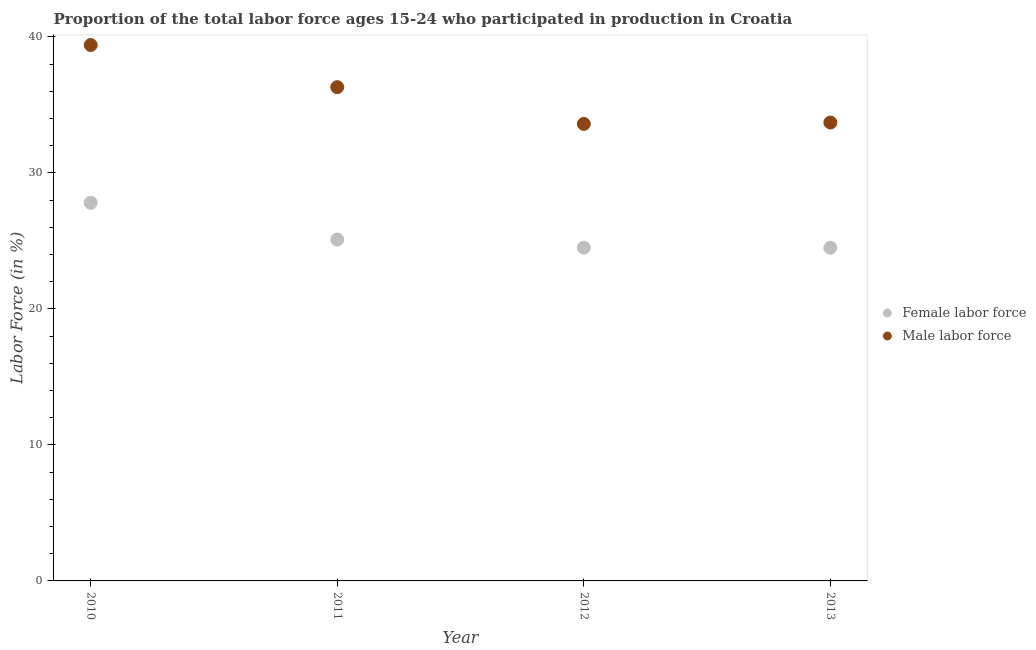How many different coloured dotlines are there?
Your answer should be very brief. 2. What is the percentage of female labor force in 2011?
Offer a very short reply. 25.1. Across all years, what is the maximum percentage of female labor force?
Provide a succinct answer. 27.8. Across all years, what is the minimum percentage of male labour force?
Ensure brevity in your answer.  33.6. In which year was the percentage of male labour force maximum?
Provide a short and direct response. 2010. In which year was the percentage of male labour force minimum?
Your answer should be compact. 2012. What is the total percentage of male labour force in the graph?
Make the answer very short. 143. What is the difference between the percentage of male labour force in 2010 and that in 2012?
Offer a very short reply. 5.8. What is the difference between the percentage of male labour force in 2011 and the percentage of female labor force in 2013?
Your answer should be very brief. 11.8. What is the average percentage of male labour force per year?
Ensure brevity in your answer.  35.75. In the year 2010, what is the difference between the percentage of male labour force and percentage of female labor force?
Offer a very short reply. 11.6. What is the ratio of the percentage of female labor force in 2010 to that in 2011?
Give a very brief answer. 1.11. Is the percentage of female labor force in 2011 less than that in 2013?
Provide a short and direct response. No. Is the difference between the percentage of female labor force in 2012 and 2013 greater than the difference between the percentage of male labour force in 2012 and 2013?
Offer a very short reply. Yes. What is the difference between the highest and the second highest percentage of female labor force?
Provide a succinct answer. 2.7. What is the difference between the highest and the lowest percentage of female labor force?
Keep it short and to the point. 3.3. In how many years, is the percentage of male labour force greater than the average percentage of male labour force taken over all years?
Your answer should be compact. 2. Is the percentage of female labor force strictly less than the percentage of male labour force over the years?
Keep it short and to the point. Yes. How many years are there in the graph?
Provide a succinct answer. 4. What is the difference between two consecutive major ticks on the Y-axis?
Your answer should be compact. 10. Are the values on the major ticks of Y-axis written in scientific E-notation?
Ensure brevity in your answer.  No. Does the graph contain grids?
Provide a succinct answer. No. What is the title of the graph?
Provide a short and direct response. Proportion of the total labor force ages 15-24 who participated in production in Croatia. Does "Arms imports" appear as one of the legend labels in the graph?
Your response must be concise. No. What is the label or title of the X-axis?
Your response must be concise. Year. What is the Labor Force (in %) of Female labor force in 2010?
Make the answer very short. 27.8. What is the Labor Force (in %) in Male labor force in 2010?
Ensure brevity in your answer.  39.4. What is the Labor Force (in %) of Female labor force in 2011?
Make the answer very short. 25.1. What is the Labor Force (in %) in Male labor force in 2011?
Ensure brevity in your answer.  36.3. What is the Labor Force (in %) of Female labor force in 2012?
Provide a short and direct response. 24.5. What is the Labor Force (in %) of Male labor force in 2012?
Your answer should be compact. 33.6. What is the Labor Force (in %) of Male labor force in 2013?
Give a very brief answer. 33.7. Across all years, what is the maximum Labor Force (in %) in Female labor force?
Offer a very short reply. 27.8. Across all years, what is the maximum Labor Force (in %) of Male labor force?
Your response must be concise. 39.4. Across all years, what is the minimum Labor Force (in %) in Male labor force?
Your response must be concise. 33.6. What is the total Labor Force (in %) in Female labor force in the graph?
Ensure brevity in your answer.  101.9. What is the total Labor Force (in %) of Male labor force in the graph?
Provide a succinct answer. 143. What is the difference between the Labor Force (in %) of Male labor force in 2010 and that in 2011?
Provide a succinct answer. 3.1. What is the difference between the Labor Force (in %) of Female labor force in 2010 and that in 2012?
Offer a very short reply. 3.3. What is the difference between the Labor Force (in %) in Male labor force in 2010 and that in 2013?
Offer a terse response. 5.7. What is the difference between the Labor Force (in %) of Female labor force in 2011 and that in 2012?
Give a very brief answer. 0.6. What is the difference between the Labor Force (in %) in Male labor force in 2011 and that in 2012?
Your response must be concise. 2.7. What is the difference between the Labor Force (in %) in Male labor force in 2011 and that in 2013?
Give a very brief answer. 2.6. What is the difference between the Labor Force (in %) of Female labor force in 2010 and the Labor Force (in %) of Male labor force in 2011?
Offer a very short reply. -8.5. What is the difference between the Labor Force (in %) of Female labor force in 2010 and the Labor Force (in %) of Male labor force in 2012?
Provide a succinct answer. -5.8. What is the difference between the Labor Force (in %) in Female labor force in 2011 and the Labor Force (in %) in Male labor force in 2013?
Offer a very short reply. -8.6. What is the average Labor Force (in %) of Female labor force per year?
Make the answer very short. 25.48. What is the average Labor Force (in %) of Male labor force per year?
Ensure brevity in your answer.  35.75. In the year 2011, what is the difference between the Labor Force (in %) of Female labor force and Labor Force (in %) of Male labor force?
Give a very brief answer. -11.2. In the year 2013, what is the difference between the Labor Force (in %) in Female labor force and Labor Force (in %) in Male labor force?
Give a very brief answer. -9.2. What is the ratio of the Labor Force (in %) of Female labor force in 2010 to that in 2011?
Give a very brief answer. 1.11. What is the ratio of the Labor Force (in %) of Male labor force in 2010 to that in 2011?
Offer a terse response. 1.09. What is the ratio of the Labor Force (in %) of Female labor force in 2010 to that in 2012?
Ensure brevity in your answer.  1.13. What is the ratio of the Labor Force (in %) in Male labor force in 2010 to that in 2012?
Make the answer very short. 1.17. What is the ratio of the Labor Force (in %) in Female labor force in 2010 to that in 2013?
Your response must be concise. 1.13. What is the ratio of the Labor Force (in %) in Male labor force in 2010 to that in 2013?
Ensure brevity in your answer.  1.17. What is the ratio of the Labor Force (in %) of Female labor force in 2011 to that in 2012?
Your answer should be compact. 1.02. What is the ratio of the Labor Force (in %) in Male labor force in 2011 to that in 2012?
Your answer should be very brief. 1.08. What is the ratio of the Labor Force (in %) in Female labor force in 2011 to that in 2013?
Give a very brief answer. 1.02. What is the ratio of the Labor Force (in %) in Male labor force in 2011 to that in 2013?
Your response must be concise. 1.08. What is the difference between the highest and the second highest Labor Force (in %) of Female labor force?
Offer a very short reply. 2.7. What is the difference between the highest and the second highest Labor Force (in %) in Male labor force?
Your answer should be very brief. 3.1. What is the difference between the highest and the lowest Labor Force (in %) in Female labor force?
Keep it short and to the point. 3.3. 